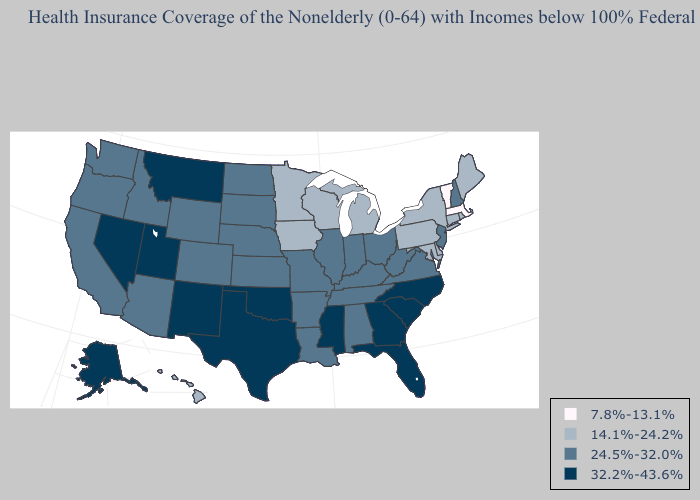What is the value of Vermont?
Write a very short answer. 7.8%-13.1%. Among the states that border Nebraska , does Iowa have the highest value?
Quick response, please. No. Does California have a higher value than Michigan?
Be succinct. Yes. Name the states that have a value in the range 32.2%-43.6%?
Be succinct. Alaska, Florida, Georgia, Mississippi, Montana, Nevada, New Mexico, North Carolina, Oklahoma, South Carolina, Texas, Utah. What is the highest value in states that border North Dakota?
Concise answer only. 32.2%-43.6%. What is the highest value in states that border Tennessee?
Concise answer only. 32.2%-43.6%. Among the states that border Arkansas , does Missouri have the lowest value?
Write a very short answer. Yes. What is the highest value in states that border South Carolina?
Quick response, please. 32.2%-43.6%. Which states have the lowest value in the West?
Write a very short answer. Hawaii. What is the highest value in the Northeast ?
Short answer required. 24.5%-32.0%. Does Maryland have the lowest value in the South?
Write a very short answer. Yes. Which states have the highest value in the USA?
Quick response, please. Alaska, Florida, Georgia, Mississippi, Montana, Nevada, New Mexico, North Carolina, Oklahoma, South Carolina, Texas, Utah. Name the states that have a value in the range 14.1%-24.2%?
Write a very short answer. Connecticut, Delaware, Hawaii, Iowa, Maine, Maryland, Michigan, Minnesota, New York, Pennsylvania, Rhode Island, Wisconsin. Name the states that have a value in the range 32.2%-43.6%?
Answer briefly. Alaska, Florida, Georgia, Mississippi, Montana, Nevada, New Mexico, North Carolina, Oklahoma, South Carolina, Texas, Utah. What is the highest value in the Northeast ?
Write a very short answer. 24.5%-32.0%. 